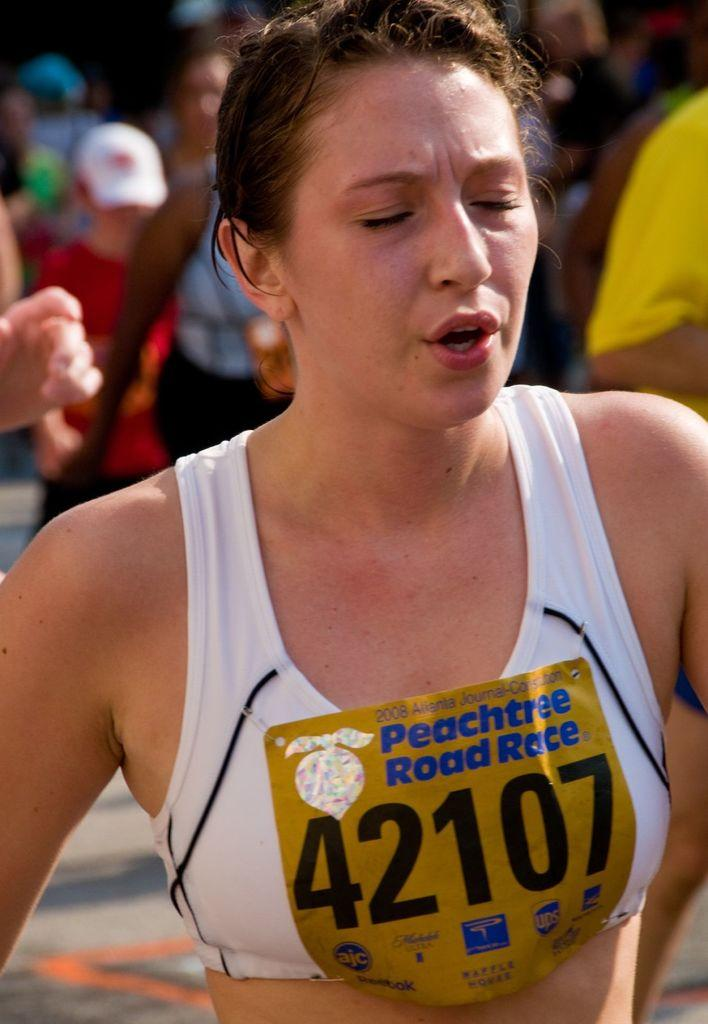<image>
Render a clear and concise summary of the photo. The lady is running in the Peachtree Road Race. 